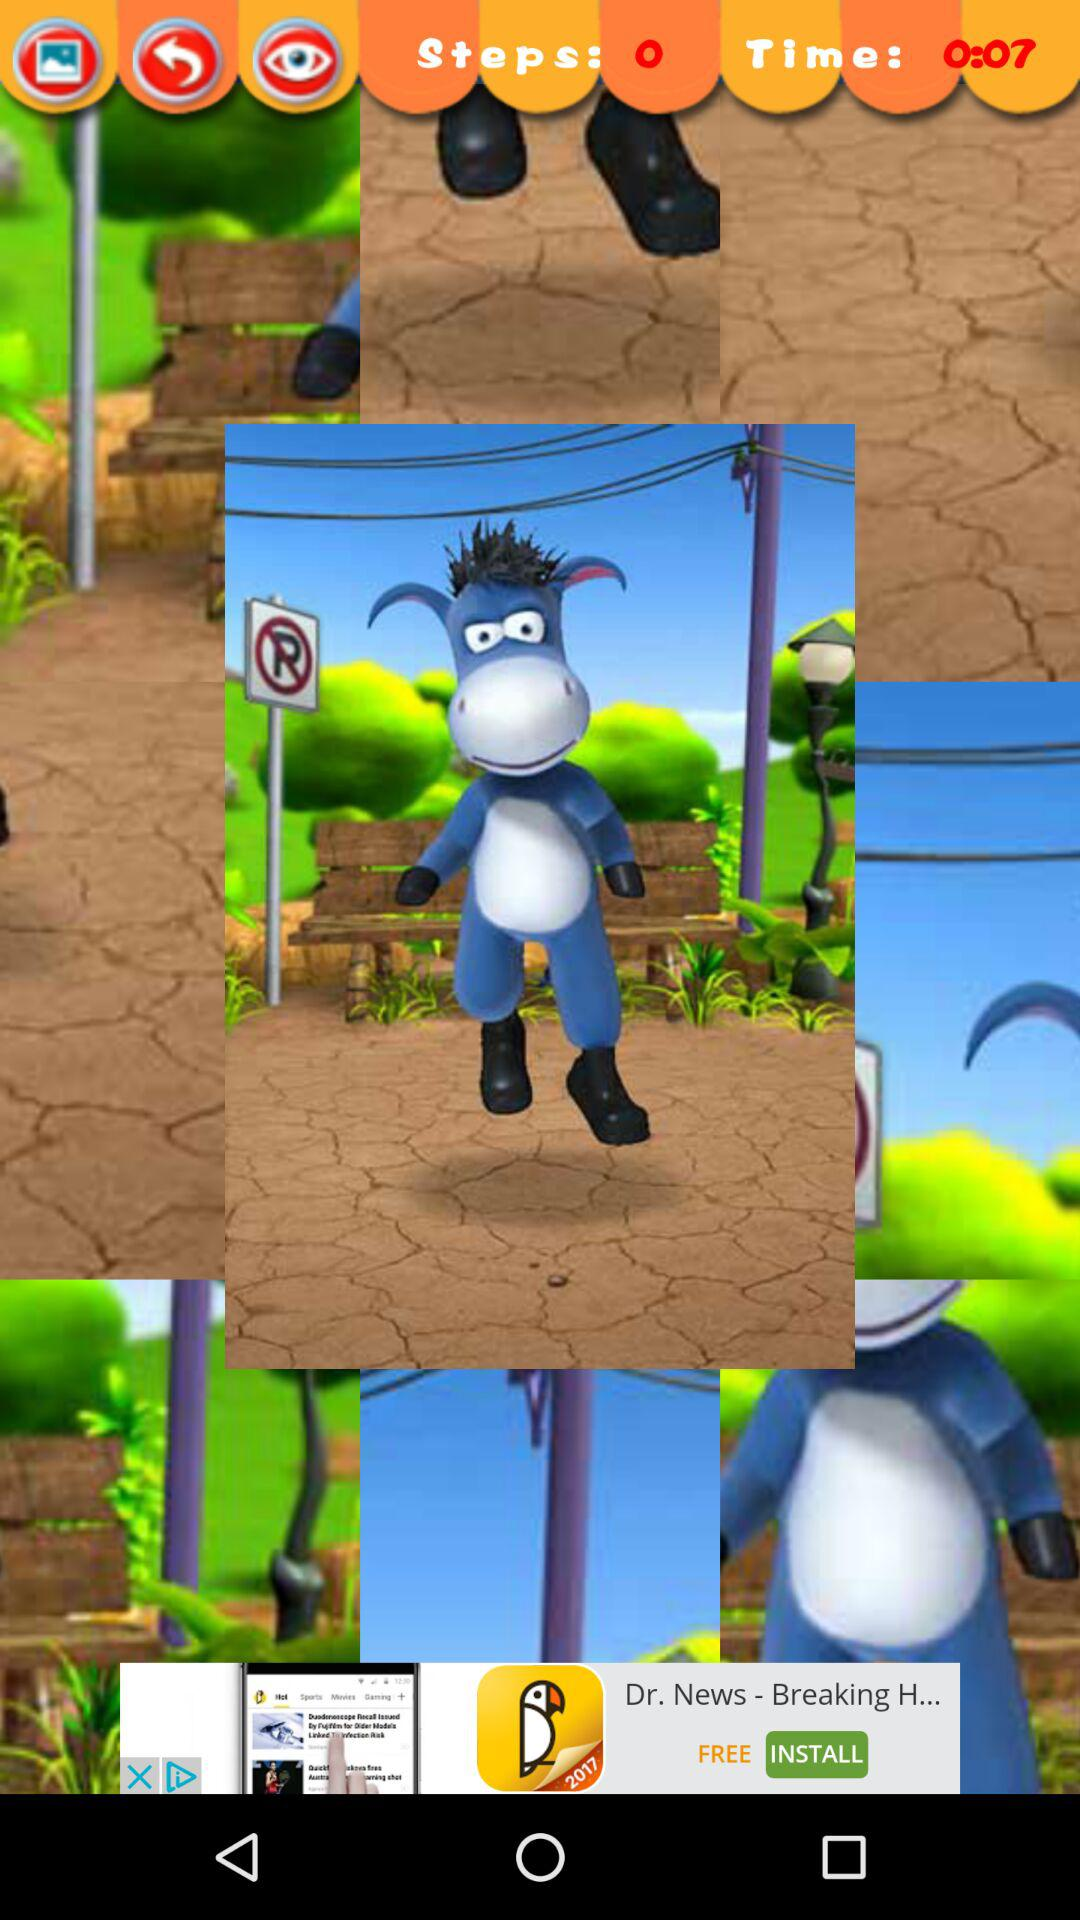What is the duration? The duration is 7 seconds. 